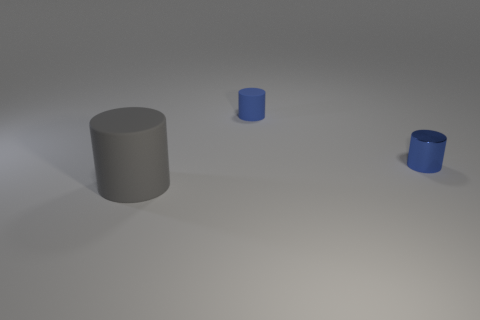Subtract all small blue cylinders. How many cylinders are left? 1 Subtract 1 cylinders. How many cylinders are left? 2 Subtract all blue cylinders. How many cylinders are left? 1 Add 3 big purple blocks. How many objects exist? 6 Subtract all yellow balls. How many green cylinders are left? 0 Add 1 small rubber cylinders. How many small rubber cylinders exist? 2 Subtract 0 purple cubes. How many objects are left? 3 Subtract all gray cylinders. Subtract all purple balls. How many cylinders are left? 2 Subtract all tiny matte things. Subtract all large gray cylinders. How many objects are left? 1 Add 1 tiny blue objects. How many tiny blue objects are left? 3 